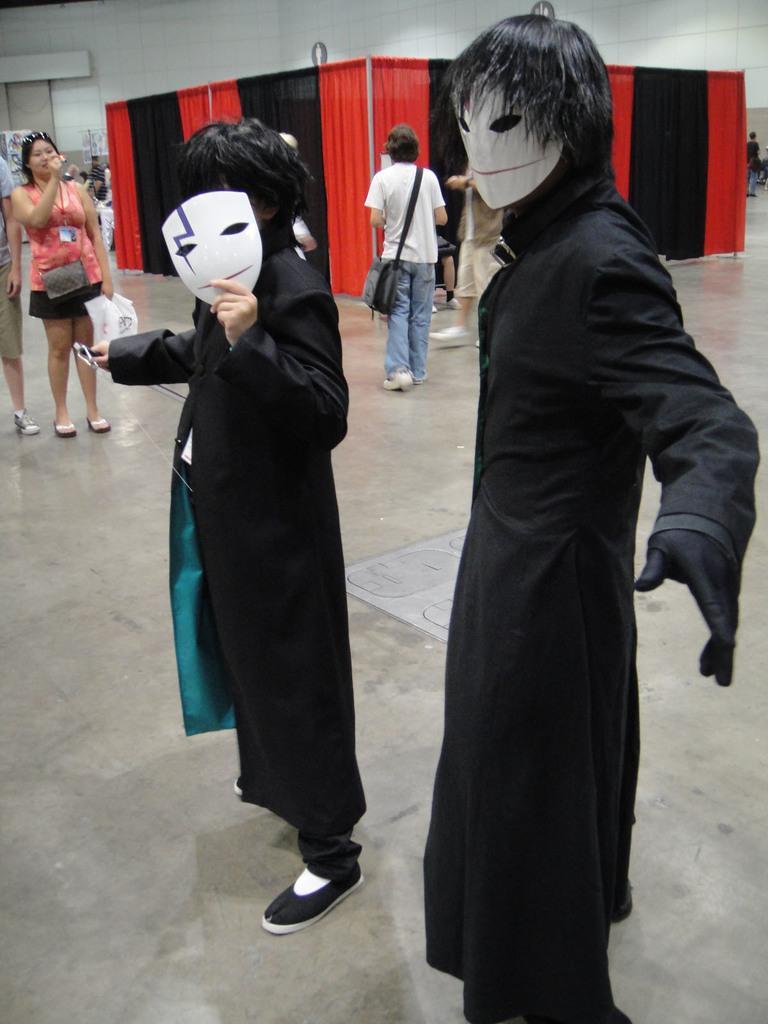Please provide a concise description of this image. In this image in front there are people wearing a mask. Behind them there are a few other people standing on the floor. There are curtains. In the background of the image there is a wall. 